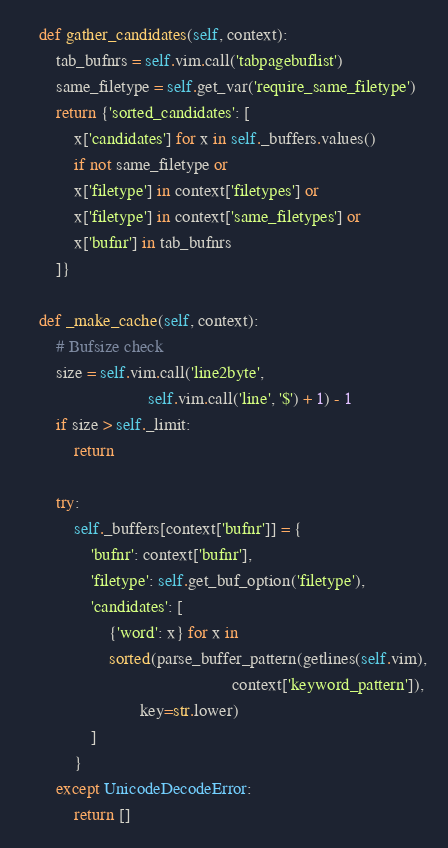<code> <loc_0><loc_0><loc_500><loc_500><_Python_>    def gather_candidates(self, context):
        tab_bufnrs = self.vim.call('tabpagebuflist')
        same_filetype = self.get_var('require_same_filetype')
        return {'sorted_candidates': [
            x['candidates'] for x in self._buffers.values()
            if not same_filetype or
            x['filetype'] in context['filetypes'] or
            x['filetype'] in context['same_filetypes'] or
            x['bufnr'] in tab_bufnrs
        ]}

    def _make_cache(self, context):
        # Bufsize check
        size = self.vim.call('line2byte',
                             self.vim.call('line', '$') + 1) - 1
        if size > self._limit:
            return

        try:
            self._buffers[context['bufnr']] = {
                'bufnr': context['bufnr'],
                'filetype': self.get_buf_option('filetype'),
                'candidates': [
                    {'word': x} for x in
                    sorted(parse_buffer_pattern(getlines(self.vim),
                                                context['keyword_pattern']),
                           key=str.lower)
                ]
            }
        except UnicodeDecodeError:
            return []
</code> 